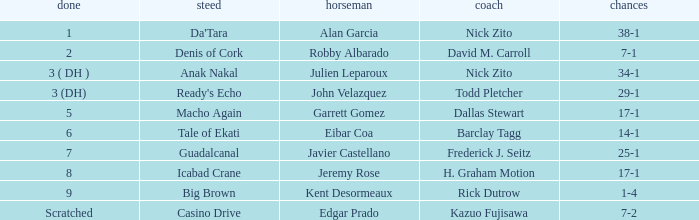What are the Odds for Trainer Barclay Tagg? 14-1. 